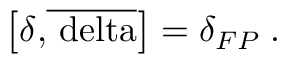Convert formula to latex. <formula><loc_0><loc_0><loc_500><loc_500>\left [ \delta { , } \overline { \ d e l t a } \right ] = \delta _ { F P } \, .</formula> 